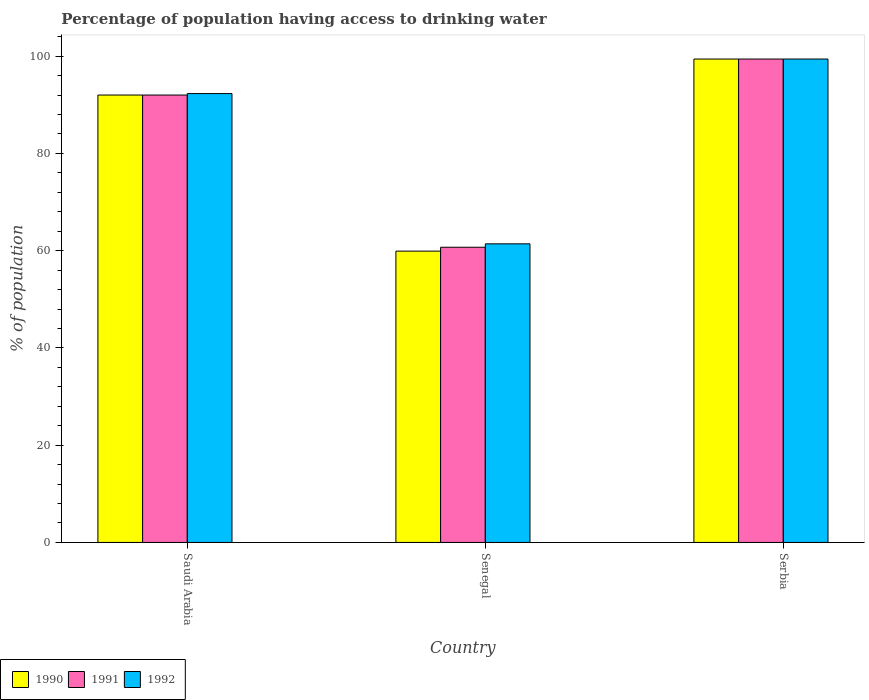How many different coloured bars are there?
Make the answer very short. 3. How many bars are there on the 2nd tick from the left?
Your answer should be compact. 3. How many bars are there on the 2nd tick from the right?
Your response must be concise. 3. What is the label of the 3rd group of bars from the left?
Offer a terse response. Serbia. What is the percentage of population having access to drinking water in 1992 in Senegal?
Your answer should be compact. 61.4. Across all countries, what is the maximum percentage of population having access to drinking water in 1992?
Offer a terse response. 99.4. Across all countries, what is the minimum percentage of population having access to drinking water in 1990?
Your answer should be very brief. 59.9. In which country was the percentage of population having access to drinking water in 1992 maximum?
Provide a succinct answer. Serbia. In which country was the percentage of population having access to drinking water in 1990 minimum?
Your answer should be compact. Senegal. What is the total percentage of population having access to drinking water in 1991 in the graph?
Ensure brevity in your answer.  252.1. What is the difference between the percentage of population having access to drinking water in 1992 in Senegal and that in Serbia?
Offer a terse response. -38. What is the difference between the percentage of population having access to drinking water in 1991 in Saudi Arabia and the percentage of population having access to drinking water in 1992 in Serbia?
Keep it short and to the point. -7.4. What is the average percentage of population having access to drinking water in 1990 per country?
Your answer should be compact. 83.77. What is the ratio of the percentage of population having access to drinking water in 1992 in Saudi Arabia to that in Serbia?
Your response must be concise. 0.93. Is the percentage of population having access to drinking water in 1991 in Saudi Arabia less than that in Senegal?
Your answer should be very brief. No. Is the difference between the percentage of population having access to drinking water in 1992 in Saudi Arabia and Senegal greater than the difference between the percentage of population having access to drinking water in 1990 in Saudi Arabia and Senegal?
Offer a terse response. No. What is the difference between the highest and the second highest percentage of population having access to drinking water in 1992?
Ensure brevity in your answer.  7.1. What is the difference between the highest and the lowest percentage of population having access to drinking water in 1992?
Provide a succinct answer. 38. In how many countries, is the percentage of population having access to drinking water in 1990 greater than the average percentage of population having access to drinking water in 1990 taken over all countries?
Keep it short and to the point. 2. What is the difference between two consecutive major ticks on the Y-axis?
Keep it short and to the point. 20. What is the title of the graph?
Give a very brief answer. Percentage of population having access to drinking water. What is the label or title of the X-axis?
Make the answer very short. Country. What is the label or title of the Y-axis?
Keep it short and to the point. % of population. What is the % of population of 1990 in Saudi Arabia?
Offer a very short reply. 92. What is the % of population in 1991 in Saudi Arabia?
Offer a terse response. 92. What is the % of population of 1992 in Saudi Arabia?
Provide a succinct answer. 92.3. What is the % of population in 1990 in Senegal?
Keep it short and to the point. 59.9. What is the % of population in 1991 in Senegal?
Ensure brevity in your answer.  60.7. What is the % of population in 1992 in Senegal?
Provide a short and direct response. 61.4. What is the % of population of 1990 in Serbia?
Your answer should be compact. 99.4. What is the % of population of 1991 in Serbia?
Provide a short and direct response. 99.4. What is the % of population in 1992 in Serbia?
Make the answer very short. 99.4. Across all countries, what is the maximum % of population in 1990?
Keep it short and to the point. 99.4. Across all countries, what is the maximum % of population in 1991?
Your answer should be compact. 99.4. Across all countries, what is the maximum % of population of 1992?
Your answer should be compact. 99.4. Across all countries, what is the minimum % of population of 1990?
Make the answer very short. 59.9. Across all countries, what is the minimum % of population in 1991?
Your answer should be compact. 60.7. Across all countries, what is the minimum % of population in 1992?
Provide a short and direct response. 61.4. What is the total % of population of 1990 in the graph?
Provide a succinct answer. 251.3. What is the total % of population of 1991 in the graph?
Give a very brief answer. 252.1. What is the total % of population in 1992 in the graph?
Provide a succinct answer. 253.1. What is the difference between the % of population of 1990 in Saudi Arabia and that in Senegal?
Provide a succinct answer. 32.1. What is the difference between the % of population in 1991 in Saudi Arabia and that in Senegal?
Make the answer very short. 31.3. What is the difference between the % of population in 1992 in Saudi Arabia and that in Senegal?
Keep it short and to the point. 30.9. What is the difference between the % of population in 1991 in Saudi Arabia and that in Serbia?
Offer a very short reply. -7.4. What is the difference between the % of population of 1992 in Saudi Arabia and that in Serbia?
Your answer should be compact. -7.1. What is the difference between the % of population of 1990 in Senegal and that in Serbia?
Keep it short and to the point. -39.5. What is the difference between the % of population of 1991 in Senegal and that in Serbia?
Provide a succinct answer. -38.7. What is the difference between the % of population of 1992 in Senegal and that in Serbia?
Offer a very short reply. -38. What is the difference between the % of population of 1990 in Saudi Arabia and the % of population of 1991 in Senegal?
Offer a terse response. 31.3. What is the difference between the % of population in 1990 in Saudi Arabia and the % of population in 1992 in Senegal?
Make the answer very short. 30.6. What is the difference between the % of population in 1991 in Saudi Arabia and the % of population in 1992 in Senegal?
Give a very brief answer. 30.6. What is the difference between the % of population in 1990 in Saudi Arabia and the % of population in 1991 in Serbia?
Offer a very short reply. -7.4. What is the difference between the % of population of 1990 in Senegal and the % of population of 1991 in Serbia?
Make the answer very short. -39.5. What is the difference between the % of population in 1990 in Senegal and the % of population in 1992 in Serbia?
Provide a short and direct response. -39.5. What is the difference between the % of population in 1991 in Senegal and the % of population in 1992 in Serbia?
Give a very brief answer. -38.7. What is the average % of population of 1990 per country?
Give a very brief answer. 83.77. What is the average % of population in 1991 per country?
Ensure brevity in your answer.  84.03. What is the average % of population in 1992 per country?
Offer a terse response. 84.37. What is the difference between the % of population in 1991 and % of population in 1992 in Saudi Arabia?
Ensure brevity in your answer.  -0.3. What is the difference between the % of population of 1990 and % of population of 1992 in Serbia?
Your answer should be compact. 0. What is the ratio of the % of population of 1990 in Saudi Arabia to that in Senegal?
Provide a short and direct response. 1.54. What is the ratio of the % of population of 1991 in Saudi Arabia to that in Senegal?
Make the answer very short. 1.52. What is the ratio of the % of population in 1992 in Saudi Arabia to that in Senegal?
Make the answer very short. 1.5. What is the ratio of the % of population in 1990 in Saudi Arabia to that in Serbia?
Make the answer very short. 0.93. What is the ratio of the % of population in 1991 in Saudi Arabia to that in Serbia?
Your answer should be very brief. 0.93. What is the ratio of the % of population in 1990 in Senegal to that in Serbia?
Make the answer very short. 0.6. What is the ratio of the % of population of 1991 in Senegal to that in Serbia?
Ensure brevity in your answer.  0.61. What is the ratio of the % of population in 1992 in Senegal to that in Serbia?
Provide a succinct answer. 0.62. What is the difference between the highest and the second highest % of population of 1990?
Offer a very short reply. 7.4. What is the difference between the highest and the second highest % of population of 1992?
Your answer should be compact. 7.1. What is the difference between the highest and the lowest % of population in 1990?
Your answer should be very brief. 39.5. What is the difference between the highest and the lowest % of population of 1991?
Keep it short and to the point. 38.7. What is the difference between the highest and the lowest % of population of 1992?
Offer a very short reply. 38. 